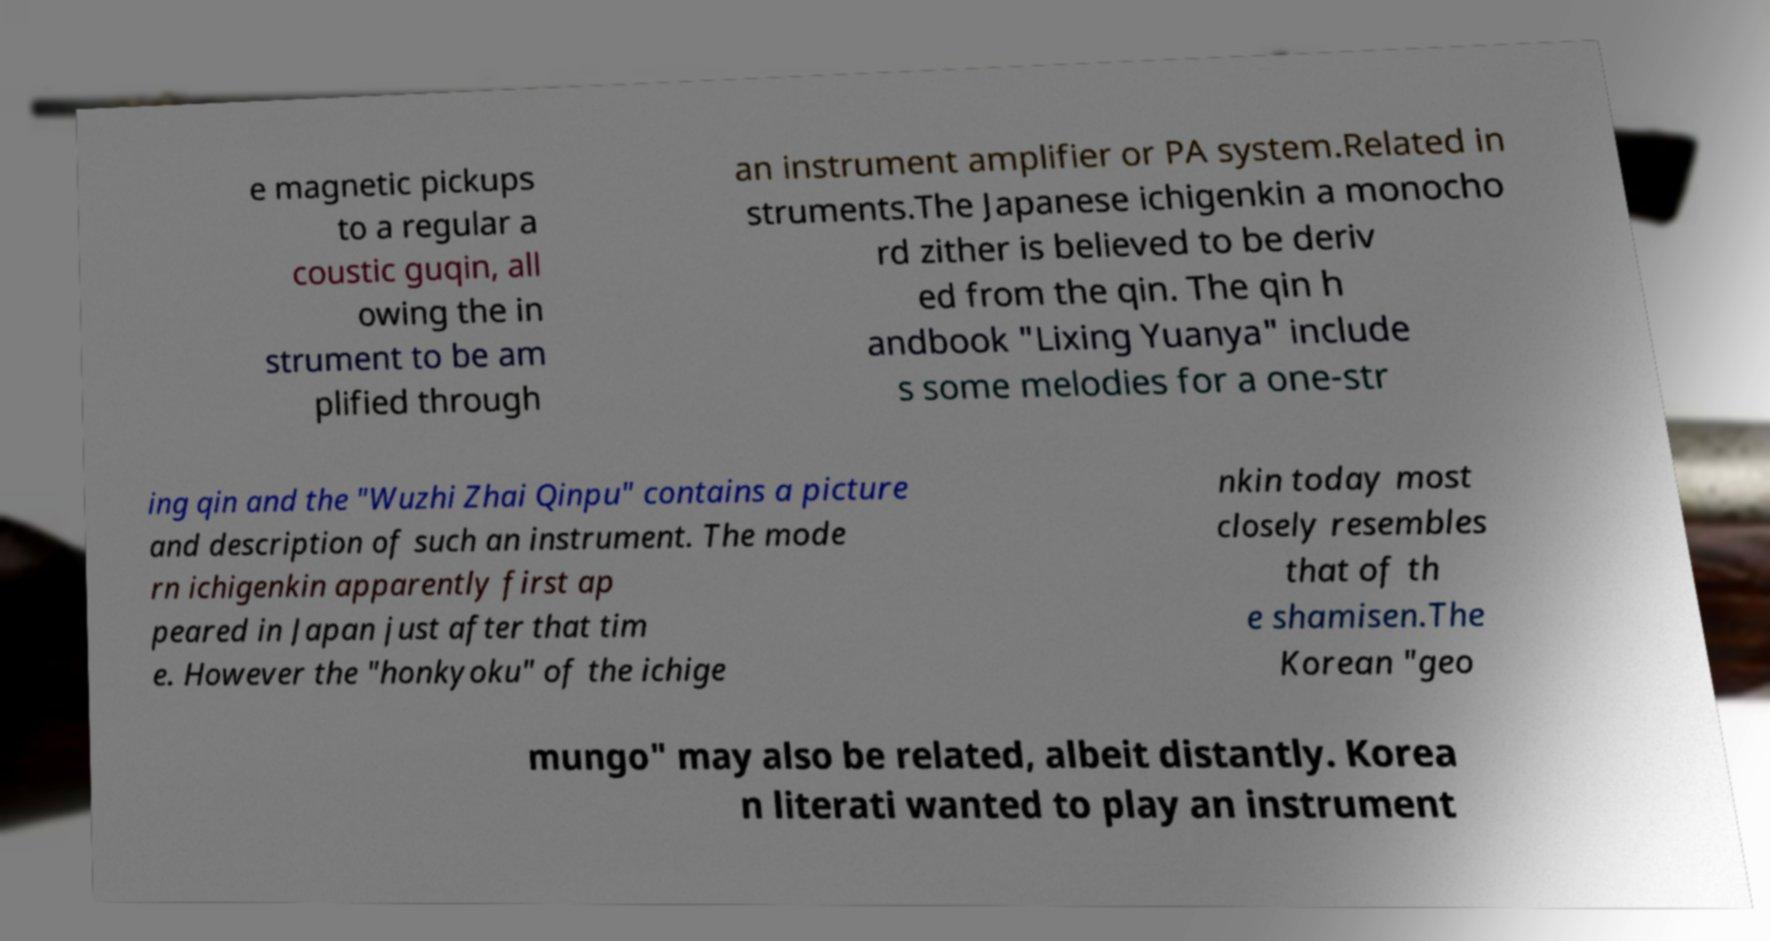For documentation purposes, I need the text within this image transcribed. Could you provide that? e magnetic pickups to a regular a coustic guqin, all owing the in strument to be am plified through an instrument amplifier or PA system.Related in struments.The Japanese ichigenkin a monocho rd zither is believed to be deriv ed from the qin. The qin h andbook "Lixing Yuanya" include s some melodies for a one-str ing qin and the "Wuzhi Zhai Qinpu" contains a picture and description of such an instrument. The mode rn ichigenkin apparently first ap peared in Japan just after that tim e. However the "honkyoku" of the ichige nkin today most closely resembles that of th e shamisen.The Korean "geo mungo" may also be related, albeit distantly. Korea n literati wanted to play an instrument 